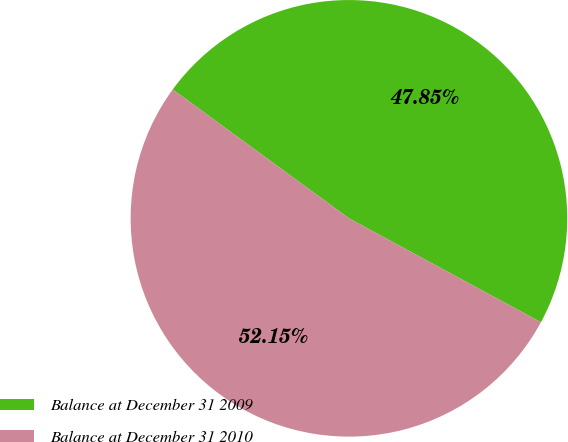Convert chart to OTSL. <chart><loc_0><loc_0><loc_500><loc_500><pie_chart><fcel>Balance at December 31 2009<fcel>Balance at December 31 2010<nl><fcel>47.85%<fcel>52.15%<nl></chart> 